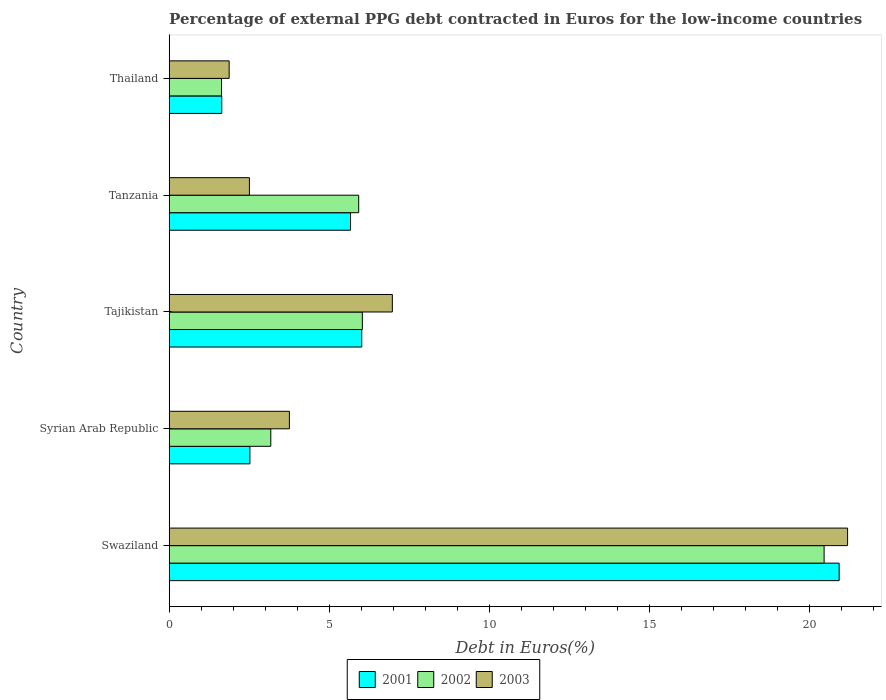How many different coloured bars are there?
Provide a short and direct response. 3. How many groups of bars are there?
Offer a terse response. 5. What is the label of the 2nd group of bars from the top?
Offer a terse response. Tanzania. What is the percentage of external PPG debt contracted in Euros in 2003 in Tajikistan?
Your answer should be compact. 6.97. Across all countries, what is the maximum percentage of external PPG debt contracted in Euros in 2002?
Your response must be concise. 20.47. Across all countries, what is the minimum percentage of external PPG debt contracted in Euros in 2001?
Give a very brief answer. 1.64. In which country was the percentage of external PPG debt contracted in Euros in 2001 maximum?
Provide a succinct answer. Swaziland. In which country was the percentage of external PPG debt contracted in Euros in 2002 minimum?
Your response must be concise. Thailand. What is the total percentage of external PPG debt contracted in Euros in 2003 in the graph?
Ensure brevity in your answer.  36.31. What is the difference between the percentage of external PPG debt contracted in Euros in 2002 in Tanzania and that in Thailand?
Your answer should be very brief. 4.29. What is the difference between the percentage of external PPG debt contracted in Euros in 2003 in Thailand and the percentage of external PPG debt contracted in Euros in 2001 in Swaziland?
Offer a terse response. -19.06. What is the average percentage of external PPG debt contracted in Euros in 2003 per country?
Provide a succinct answer. 7.26. What is the difference between the percentage of external PPG debt contracted in Euros in 2001 and percentage of external PPG debt contracted in Euros in 2003 in Tanzania?
Ensure brevity in your answer.  3.16. What is the ratio of the percentage of external PPG debt contracted in Euros in 2001 in Swaziland to that in Tanzania?
Ensure brevity in your answer.  3.69. Is the percentage of external PPG debt contracted in Euros in 2002 in Swaziland less than that in Thailand?
Keep it short and to the point. No. What is the difference between the highest and the second highest percentage of external PPG debt contracted in Euros in 2001?
Offer a very short reply. 14.92. What is the difference between the highest and the lowest percentage of external PPG debt contracted in Euros in 2003?
Ensure brevity in your answer.  19.33. In how many countries, is the percentage of external PPG debt contracted in Euros in 2003 greater than the average percentage of external PPG debt contracted in Euros in 2003 taken over all countries?
Your answer should be compact. 1. What does the 3rd bar from the top in Tanzania represents?
Keep it short and to the point. 2001. What does the 2nd bar from the bottom in Swaziland represents?
Offer a very short reply. 2002. Is it the case that in every country, the sum of the percentage of external PPG debt contracted in Euros in 2001 and percentage of external PPG debt contracted in Euros in 2003 is greater than the percentage of external PPG debt contracted in Euros in 2002?
Your answer should be very brief. Yes. How many bars are there?
Your response must be concise. 15. How many countries are there in the graph?
Make the answer very short. 5. What is the difference between two consecutive major ticks on the X-axis?
Offer a very short reply. 5. Does the graph contain grids?
Give a very brief answer. No. Where does the legend appear in the graph?
Provide a short and direct response. Bottom center. What is the title of the graph?
Your answer should be very brief. Percentage of external PPG debt contracted in Euros for the low-income countries. What is the label or title of the X-axis?
Keep it short and to the point. Debt in Euros(%). What is the label or title of the Y-axis?
Provide a short and direct response. Country. What is the Debt in Euros(%) in 2001 in Swaziland?
Your response must be concise. 20.94. What is the Debt in Euros(%) in 2002 in Swaziland?
Offer a very short reply. 20.47. What is the Debt in Euros(%) of 2003 in Swaziland?
Ensure brevity in your answer.  21.2. What is the Debt in Euros(%) of 2001 in Syrian Arab Republic?
Offer a very short reply. 2.52. What is the Debt in Euros(%) in 2002 in Syrian Arab Republic?
Give a very brief answer. 3.17. What is the Debt in Euros(%) of 2003 in Syrian Arab Republic?
Your response must be concise. 3.76. What is the Debt in Euros(%) in 2001 in Tajikistan?
Offer a very short reply. 6.02. What is the Debt in Euros(%) in 2002 in Tajikistan?
Give a very brief answer. 6.04. What is the Debt in Euros(%) of 2003 in Tajikistan?
Provide a short and direct response. 6.97. What is the Debt in Euros(%) of 2001 in Tanzania?
Your response must be concise. 5.67. What is the Debt in Euros(%) in 2002 in Tanzania?
Ensure brevity in your answer.  5.92. What is the Debt in Euros(%) in 2003 in Tanzania?
Provide a short and direct response. 2.51. What is the Debt in Euros(%) in 2001 in Thailand?
Make the answer very short. 1.64. What is the Debt in Euros(%) in 2002 in Thailand?
Offer a terse response. 1.64. What is the Debt in Euros(%) in 2003 in Thailand?
Offer a terse response. 1.87. Across all countries, what is the maximum Debt in Euros(%) in 2001?
Give a very brief answer. 20.94. Across all countries, what is the maximum Debt in Euros(%) in 2002?
Ensure brevity in your answer.  20.47. Across all countries, what is the maximum Debt in Euros(%) of 2003?
Provide a short and direct response. 21.2. Across all countries, what is the minimum Debt in Euros(%) of 2001?
Ensure brevity in your answer.  1.64. Across all countries, what is the minimum Debt in Euros(%) in 2002?
Keep it short and to the point. 1.64. Across all countries, what is the minimum Debt in Euros(%) of 2003?
Give a very brief answer. 1.87. What is the total Debt in Euros(%) in 2001 in the graph?
Make the answer very short. 36.78. What is the total Debt in Euros(%) in 2002 in the graph?
Offer a terse response. 37.23. What is the total Debt in Euros(%) of 2003 in the graph?
Offer a terse response. 36.31. What is the difference between the Debt in Euros(%) of 2001 in Swaziland and that in Syrian Arab Republic?
Offer a terse response. 18.41. What is the difference between the Debt in Euros(%) in 2002 in Swaziland and that in Syrian Arab Republic?
Your answer should be very brief. 17.29. What is the difference between the Debt in Euros(%) of 2003 in Swaziland and that in Syrian Arab Republic?
Keep it short and to the point. 17.44. What is the difference between the Debt in Euros(%) in 2001 in Swaziland and that in Tajikistan?
Your answer should be very brief. 14.92. What is the difference between the Debt in Euros(%) of 2002 in Swaziland and that in Tajikistan?
Keep it short and to the point. 14.43. What is the difference between the Debt in Euros(%) in 2003 in Swaziland and that in Tajikistan?
Give a very brief answer. 14.23. What is the difference between the Debt in Euros(%) of 2001 in Swaziland and that in Tanzania?
Offer a very short reply. 15.27. What is the difference between the Debt in Euros(%) in 2002 in Swaziland and that in Tanzania?
Your answer should be compact. 14.54. What is the difference between the Debt in Euros(%) in 2003 in Swaziland and that in Tanzania?
Make the answer very short. 18.69. What is the difference between the Debt in Euros(%) in 2001 in Swaziland and that in Thailand?
Make the answer very short. 19.29. What is the difference between the Debt in Euros(%) of 2002 in Swaziland and that in Thailand?
Provide a succinct answer. 18.83. What is the difference between the Debt in Euros(%) of 2003 in Swaziland and that in Thailand?
Your answer should be compact. 19.33. What is the difference between the Debt in Euros(%) in 2001 in Syrian Arab Republic and that in Tajikistan?
Make the answer very short. -3.5. What is the difference between the Debt in Euros(%) of 2002 in Syrian Arab Republic and that in Tajikistan?
Provide a short and direct response. -2.86. What is the difference between the Debt in Euros(%) in 2003 in Syrian Arab Republic and that in Tajikistan?
Your answer should be very brief. -3.22. What is the difference between the Debt in Euros(%) in 2001 in Syrian Arab Republic and that in Tanzania?
Keep it short and to the point. -3.15. What is the difference between the Debt in Euros(%) in 2002 in Syrian Arab Republic and that in Tanzania?
Give a very brief answer. -2.75. What is the difference between the Debt in Euros(%) of 2003 in Syrian Arab Republic and that in Tanzania?
Your answer should be very brief. 1.25. What is the difference between the Debt in Euros(%) in 2001 in Syrian Arab Republic and that in Thailand?
Provide a short and direct response. 0.88. What is the difference between the Debt in Euros(%) in 2002 in Syrian Arab Republic and that in Thailand?
Give a very brief answer. 1.54. What is the difference between the Debt in Euros(%) in 2003 in Syrian Arab Republic and that in Thailand?
Make the answer very short. 1.88. What is the difference between the Debt in Euros(%) in 2001 in Tajikistan and that in Tanzania?
Your response must be concise. 0.35. What is the difference between the Debt in Euros(%) in 2002 in Tajikistan and that in Tanzania?
Give a very brief answer. 0.11. What is the difference between the Debt in Euros(%) in 2003 in Tajikistan and that in Tanzania?
Offer a terse response. 4.47. What is the difference between the Debt in Euros(%) in 2001 in Tajikistan and that in Thailand?
Your answer should be compact. 4.37. What is the difference between the Debt in Euros(%) of 2002 in Tajikistan and that in Thailand?
Offer a very short reply. 4.4. What is the difference between the Debt in Euros(%) of 2003 in Tajikistan and that in Thailand?
Make the answer very short. 5.1. What is the difference between the Debt in Euros(%) in 2001 in Tanzania and that in Thailand?
Your answer should be compact. 4.02. What is the difference between the Debt in Euros(%) in 2002 in Tanzania and that in Thailand?
Make the answer very short. 4.29. What is the difference between the Debt in Euros(%) of 2003 in Tanzania and that in Thailand?
Offer a very short reply. 0.63. What is the difference between the Debt in Euros(%) of 2001 in Swaziland and the Debt in Euros(%) of 2002 in Syrian Arab Republic?
Keep it short and to the point. 17.76. What is the difference between the Debt in Euros(%) in 2001 in Swaziland and the Debt in Euros(%) in 2003 in Syrian Arab Republic?
Provide a short and direct response. 17.18. What is the difference between the Debt in Euros(%) of 2002 in Swaziland and the Debt in Euros(%) of 2003 in Syrian Arab Republic?
Give a very brief answer. 16.71. What is the difference between the Debt in Euros(%) in 2001 in Swaziland and the Debt in Euros(%) in 2002 in Tajikistan?
Keep it short and to the point. 14.9. What is the difference between the Debt in Euros(%) of 2001 in Swaziland and the Debt in Euros(%) of 2003 in Tajikistan?
Your answer should be very brief. 13.96. What is the difference between the Debt in Euros(%) of 2002 in Swaziland and the Debt in Euros(%) of 2003 in Tajikistan?
Your answer should be compact. 13.49. What is the difference between the Debt in Euros(%) of 2001 in Swaziland and the Debt in Euros(%) of 2002 in Tanzania?
Make the answer very short. 15.01. What is the difference between the Debt in Euros(%) in 2001 in Swaziland and the Debt in Euros(%) in 2003 in Tanzania?
Your response must be concise. 18.43. What is the difference between the Debt in Euros(%) in 2002 in Swaziland and the Debt in Euros(%) in 2003 in Tanzania?
Offer a terse response. 17.96. What is the difference between the Debt in Euros(%) of 2001 in Swaziland and the Debt in Euros(%) of 2002 in Thailand?
Offer a terse response. 19.3. What is the difference between the Debt in Euros(%) of 2001 in Swaziland and the Debt in Euros(%) of 2003 in Thailand?
Offer a terse response. 19.06. What is the difference between the Debt in Euros(%) of 2002 in Swaziland and the Debt in Euros(%) of 2003 in Thailand?
Offer a terse response. 18.59. What is the difference between the Debt in Euros(%) in 2001 in Syrian Arab Republic and the Debt in Euros(%) in 2002 in Tajikistan?
Give a very brief answer. -3.51. What is the difference between the Debt in Euros(%) in 2001 in Syrian Arab Republic and the Debt in Euros(%) in 2003 in Tajikistan?
Your answer should be compact. -4.45. What is the difference between the Debt in Euros(%) in 2002 in Syrian Arab Republic and the Debt in Euros(%) in 2003 in Tajikistan?
Your answer should be compact. -3.8. What is the difference between the Debt in Euros(%) in 2001 in Syrian Arab Republic and the Debt in Euros(%) in 2002 in Tanzania?
Keep it short and to the point. -3.4. What is the difference between the Debt in Euros(%) in 2001 in Syrian Arab Republic and the Debt in Euros(%) in 2003 in Tanzania?
Your response must be concise. 0.02. What is the difference between the Debt in Euros(%) of 2002 in Syrian Arab Republic and the Debt in Euros(%) of 2003 in Tanzania?
Your response must be concise. 0.67. What is the difference between the Debt in Euros(%) in 2001 in Syrian Arab Republic and the Debt in Euros(%) in 2002 in Thailand?
Your answer should be compact. 0.89. What is the difference between the Debt in Euros(%) of 2001 in Syrian Arab Republic and the Debt in Euros(%) of 2003 in Thailand?
Give a very brief answer. 0.65. What is the difference between the Debt in Euros(%) in 2002 in Syrian Arab Republic and the Debt in Euros(%) in 2003 in Thailand?
Offer a terse response. 1.3. What is the difference between the Debt in Euros(%) of 2001 in Tajikistan and the Debt in Euros(%) of 2002 in Tanzania?
Give a very brief answer. 0.1. What is the difference between the Debt in Euros(%) in 2001 in Tajikistan and the Debt in Euros(%) in 2003 in Tanzania?
Offer a very short reply. 3.51. What is the difference between the Debt in Euros(%) in 2002 in Tajikistan and the Debt in Euros(%) in 2003 in Tanzania?
Give a very brief answer. 3.53. What is the difference between the Debt in Euros(%) of 2001 in Tajikistan and the Debt in Euros(%) of 2002 in Thailand?
Ensure brevity in your answer.  4.38. What is the difference between the Debt in Euros(%) in 2001 in Tajikistan and the Debt in Euros(%) in 2003 in Thailand?
Provide a succinct answer. 4.14. What is the difference between the Debt in Euros(%) in 2002 in Tajikistan and the Debt in Euros(%) in 2003 in Thailand?
Provide a succinct answer. 4.16. What is the difference between the Debt in Euros(%) of 2001 in Tanzania and the Debt in Euros(%) of 2002 in Thailand?
Make the answer very short. 4.03. What is the difference between the Debt in Euros(%) in 2001 in Tanzania and the Debt in Euros(%) in 2003 in Thailand?
Ensure brevity in your answer.  3.79. What is the difference between the Debt in Euros(%) of 2002 in Tanzania and the Debt in Euros(%) of 2003 in Thailand?
Give a very brief answer. 4.05. What is the average Debt in Euros(%) of 2001 per country?
Your answer should be compact. 7.36. What is the average Debt in Euros(%) in 2002 per country?
Provide a short and direct response. 7.45. What is the average Debt in Euros(%) of 2003 per country?
Your answer should be compact. 7.26. What is the difference between the Debt in Euros(%) in 2001 and Debt in Euros(%) in 2002 in Swaziland?
Your answer should be very brief. 0.47. What is the difference between the Debt in Euros(%) in 2001 and Debt in Euros(%) in 2003 in Swaziland?
Provide a succinct answer. -0.26. What is the difference between the Debt in Euros(%) of 2002 and Debt in Euros(%) of 2003 in Swaziland?
Offer a very short reply. -0.73. What is the difference between the Debt in Euros(%) of 2001 and Debt in Euros(%) of 2002 in Syrian Arab Republic?
Offer a terse response. -0.65. What is the difference between the Debt in Euros(%) of 2001 and Debt in Euros(%) of 2003 in Syrian Arab Republic?
Offer a very short reply. -1.23. What is the difference between the Debt in Euros(%) of 2002 and Debt in Euros(%) of 2003 in Syrian Arab Republic?
Your answer should be very brief. -0.58. What is the difference between the Debt in Euros(%) in 2001 and Debt in Euros(%) in 2002 in Tajikistan?
Provide a short and direct response. -0.02. What is the difference between the Debt in Euros(%) of 2001 and Debt in Euros(%) of 2003 in Tajikistan?
Provide a succinct answer. -0.96. What is the difference between the Debt in Euros(%) in 2002 and Debt in Euros(%) in 2003 in Tajikistan?
Make the answer very short. -0.94. What is the difference between the Debt in Euros(%) in 2001 and Debt in Euros(%) in 2002 in Tanzania?
Give a very brief answer. -0.25. What is the difference between the Debt in Euros(%) of 2001 and Debt in Euros(%) of 2003 in Tanzania?
Your answer should be very brief. 3.16. What is the difference between the Debt in Euros(%) in 2002 and Debt in Euros(%) in 2003 in Tanzania?
Provide a succinct answer. 3.41. What is the difference between the Debt in Euros(%) of 2001 and Debt in Euros(%) of 2002 in Thailand?
Give a very brief answer. 0.01. What is the difference between the Debt in Euros(%) of 2001 and Debt in Euros(%) of 2003 in Thailand?
Your answer should be compact. -0.23. What is the difference between the Debt in Euros(%) in 2002 and Debt in Euros(%) in 2003 in Thailand?
Offer a very short reply. -0.24. What is the ratio of the Debt in Euros(%) of 2001 in Swaziland to that in Syrian Arab Republic?
Keep it short and to the point. 8.3. What is the ratio of the Debt in Euros(%) of 2002 in Swaziland to that in Syrian Arab Republic?
Give a very brief answer. 6.45. What is the ratio of the Debt in Euros(%) of 2003 in Swaziland to that in Syrian Arab Republic?
Your answer should be compact. 5.64. What is the ratio of the Debt in Euros(%) in 2001 in Swaziland to that in Tajikistan?
Give a very brief answer. 3.48. What is the ratio of the Debt in Euros(%) of 2002 in Swaziland to that in Tajikistan?
Provide a short and direct response. 3.39. What is the ratio of the Debt in Euros(%) in 2003 in Swaziland to that in Tajikistan?
Provide a short and direct response. 3.04. What is the ratio of the Debt in Euros(%) of 2001 in Swaziland to that in Tanzania?
Provide a short and direct response. 3.69. What is the ratio of the Debt in Euros(%) in 2002 in Swaziland to that in Tanzania?
Make the answer very short. 3.46. What is the ratio of the Debt in Euros(%) of 2003 in Swaziland to that in Tanzania?
Offer a terse response. 8.46. What is the ratio of the Debt in Euros(%) of 2001 in Swaziland to that in Thailand?
Offer a terse response. 12.75. What is the ratio of the Debt in Euros(%) in 2002 in Swaziland to that in Thailand?
Keep it short and to the point. 12.51. What is the ratio of the Debt in Euros(%) of 2003 in Swaziland to that in Thailand?
Provide a short and direct response. 11.32. What is the ratio of the Debt in Euros(%) in 2001 in Syrian Arab Republic to that in Tajikistan?
Keep it short and to the point. 0.42. What is the ratio of the Debt in Euros(%) of 2002 in Syrian Arab Republic to that in Tajikistan?
Your answer should be very brief. 0.53. What is the ratio of the Debt in Euros(%) of 2003 in Syrian Arab Republic to that in Tajikistan?
Your answer should be very brief. 0.54. What is the ratio of the Debt in Euros(%) of 2001 in Syrian Arab Republic to that in Tanzania?
Offer a very short reply. 0.45. What is the ratio of the Debt in Euros(%) of 2002 in Syrian Arab Republic to that in Tanzania?
Ensure brevity in your answer.  0.54. What is the ratio of the Debt in Euros(%) of 2003 in Syrian Arab Republic to that in Tanzania?
Provide a short and direct response. 1.5. What is the ratio of the Debt in Euros(%) in 2001 in Syrian Arab Republic to that in Thailand?
Provide a succinct answer. 1.54. What is the ratio of the Debt in Euros(%) of 2002 in Syrian Arab Republic to that in Thailand?
Provide a succinct answer. 1.94. What is the ratio of the Debt in Euros(%) of 2003 in Syrian Arab Republic to that in Thailand?
Provide a short and direct response. 2.01. What is the ratio of the Debt in Euros(%) in 2001 in Tajikistan to that in Tanzania?
Provide a short and direct response. 1.06. What is the ratio of the Debt in Euros(%) in 2002 in Tajikistan to that in Tanzania?
Ensure brevity in your answer.  1.02. What is the ratio of the Debt in Euros(%) of 2003 in Tajikistan to that in Tanzania?
Your answer should be compact. 2.78. What is the ratio of the Debt in Euros(%) in 2001 in Tajikistan to that in Thailand?
Offer a very short reply. 3.66. What is the ratio of the Debt in Euros(%) of 2002 in Tajikistan to that in Thailand?
Your response must be concise. 3.69. What is the ratio of the Debt in Euros(%) of 2003 in Tajikistan to that in Thailand?
Your response must be concise. 3.72. What is the ratio of the Debt in Euros(%) in 2001 in Tanzania to that in Thailand?
Provide a short and direct response. 3.45. What is the ratio of the Debt in Euros(%) in 2002 in Tanzania to that in Thailand?
Give a very brief answer. 3.62. What is the ratio of the Debt in Euros(%) of 2003 in Tanzania to that in Thailand?
Provide a succinct answer. 1.34. What is the difference between the highest and the second highest Debt in Euros(%) of 2001?
Give a very brief answer. 14.92. What is the difference between the highest and the second highest Debt in Euros(%) of 2002?
Your answer should be compact. 14.43. What is the difference between the highest and the second highest Debt in Euros(%) in 2003?
Ensure brevity in your answer.  14.23. What is the difference between the highest and the lowest Debt in Euros(%) of 2001?
Provide a short and direct response. 19.29. What is the difference between the highest and the lowest Debt in Euros(%) of 2002?
Your answer should be very brief. 18.83. What is the difference between the highest and the lowest Debt in Euros(%) of 2003?
Provide a succinct answer. 19.33. 